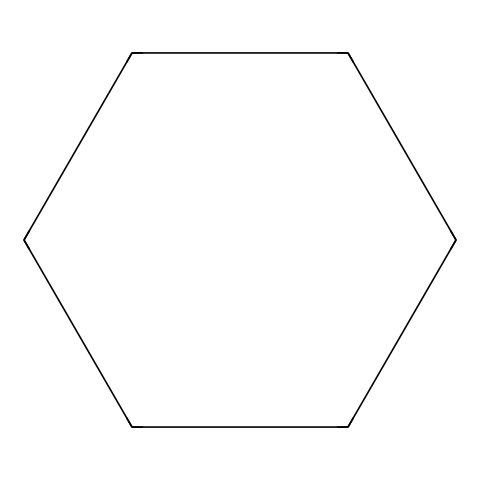What is the name of the chemical represented by this structure? The SMILES notation "C1CCCCC1" indicates a cycloalkane structure consisting of six carbon atoms arranged in a ring, which is known as cyclohexane.
Answer: cyclohexane How many carbon atoms are in the chemical structure? The SMILES representation "C1CCCCC1" shows there are six 'C' characters indicating six carbon atoms in the structure.
Answer: six How many hydrogen atoms are bonded to the carbon atoms? Each carbon in the cyclohexane structure can bond to two hydrogen atoms, leading to a total of twelve hydrogens (6 carbons x 2 hydrogens). Therefore, there are twelve hydrogen atoms in total.
Answer: twelve What is the hybridization of the carbon atoms in cyclohexane? The structure of cyclohexane shows that each carbon is involved in four single bonds (two with neighboring carbons and two with hydrogens), indicating that the hybridization state of these carbon atoms is sp3.
Answer: sp3 Is the cyclohexane molecule planar? Due to the tetrahedral arrangements of the sp3 hybridized carbon atoms, cyclohexane adopts a non-planar conformation (specifically a chair conformation), which allows for angle strain relief.
Answer: non-planar What type of bonds are present in cyclohexane? The structure shows that all the bonds between the carbon and carbon, and carbon and hydrogen, are single covalent bonds, as depicted in the chemical representation.
Answer: single covalent bonds What physical state do we expect cyclohexane to be in at room temperature? Given that cyclohexane is a liquid at room temperature (around 25 degrees Celsius), this can be inferred from its molecular structure and properties, as it does not have high molecular weight or strong intermolecular forces dictating a solid state.
Answer: liquid 